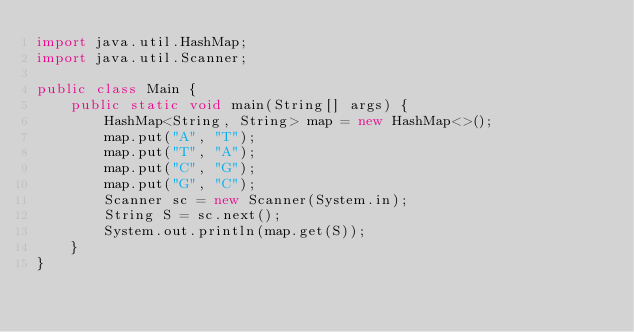<code> <loc_0><loc_0><loc_500><loc_500><_Java_>import java.util.HashMap;
import java.util.Scanner;

public class Main {
	public static void main(String[] args) {
		HashMap<String, String> map = new HashMap<>();
		map.put("A", "T");
		map.put("T", "A");
		map.put("C", "G");
		map.put("G", "C");
		Scanner sc = new Scanner(System.in);
		String S = sc.next();
		System.out.println(map.get(S));
	}
}</code> 